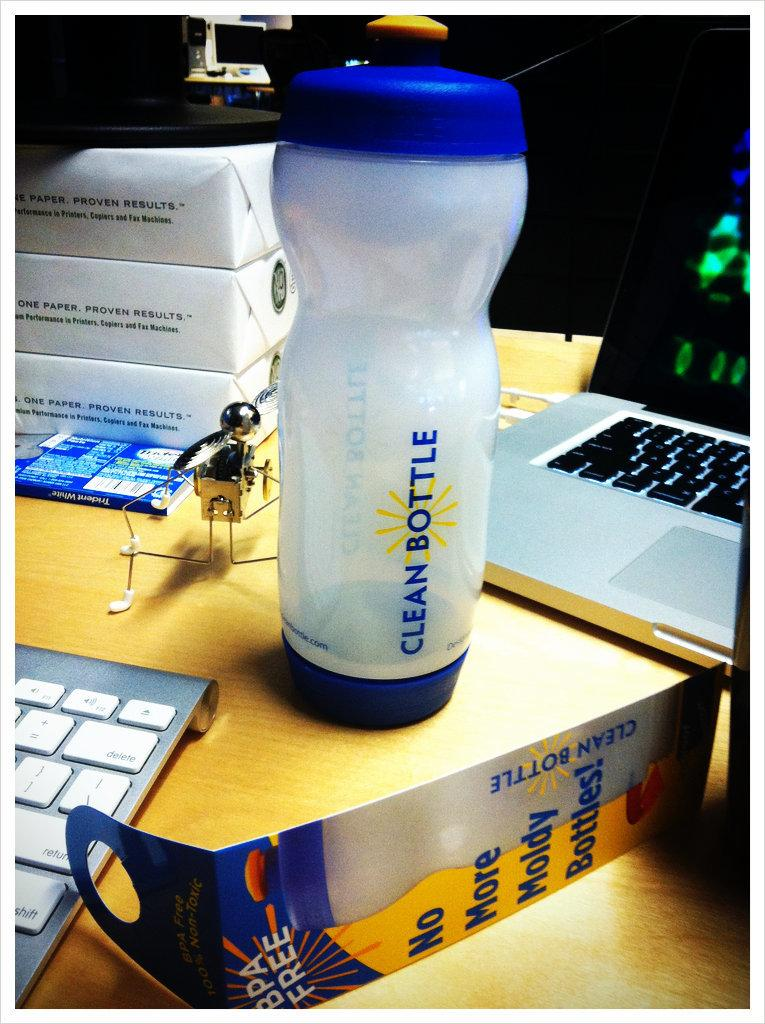Provide a one-sentence caption for the provided image. Clean Bottle water bottle next to an open laptop. 